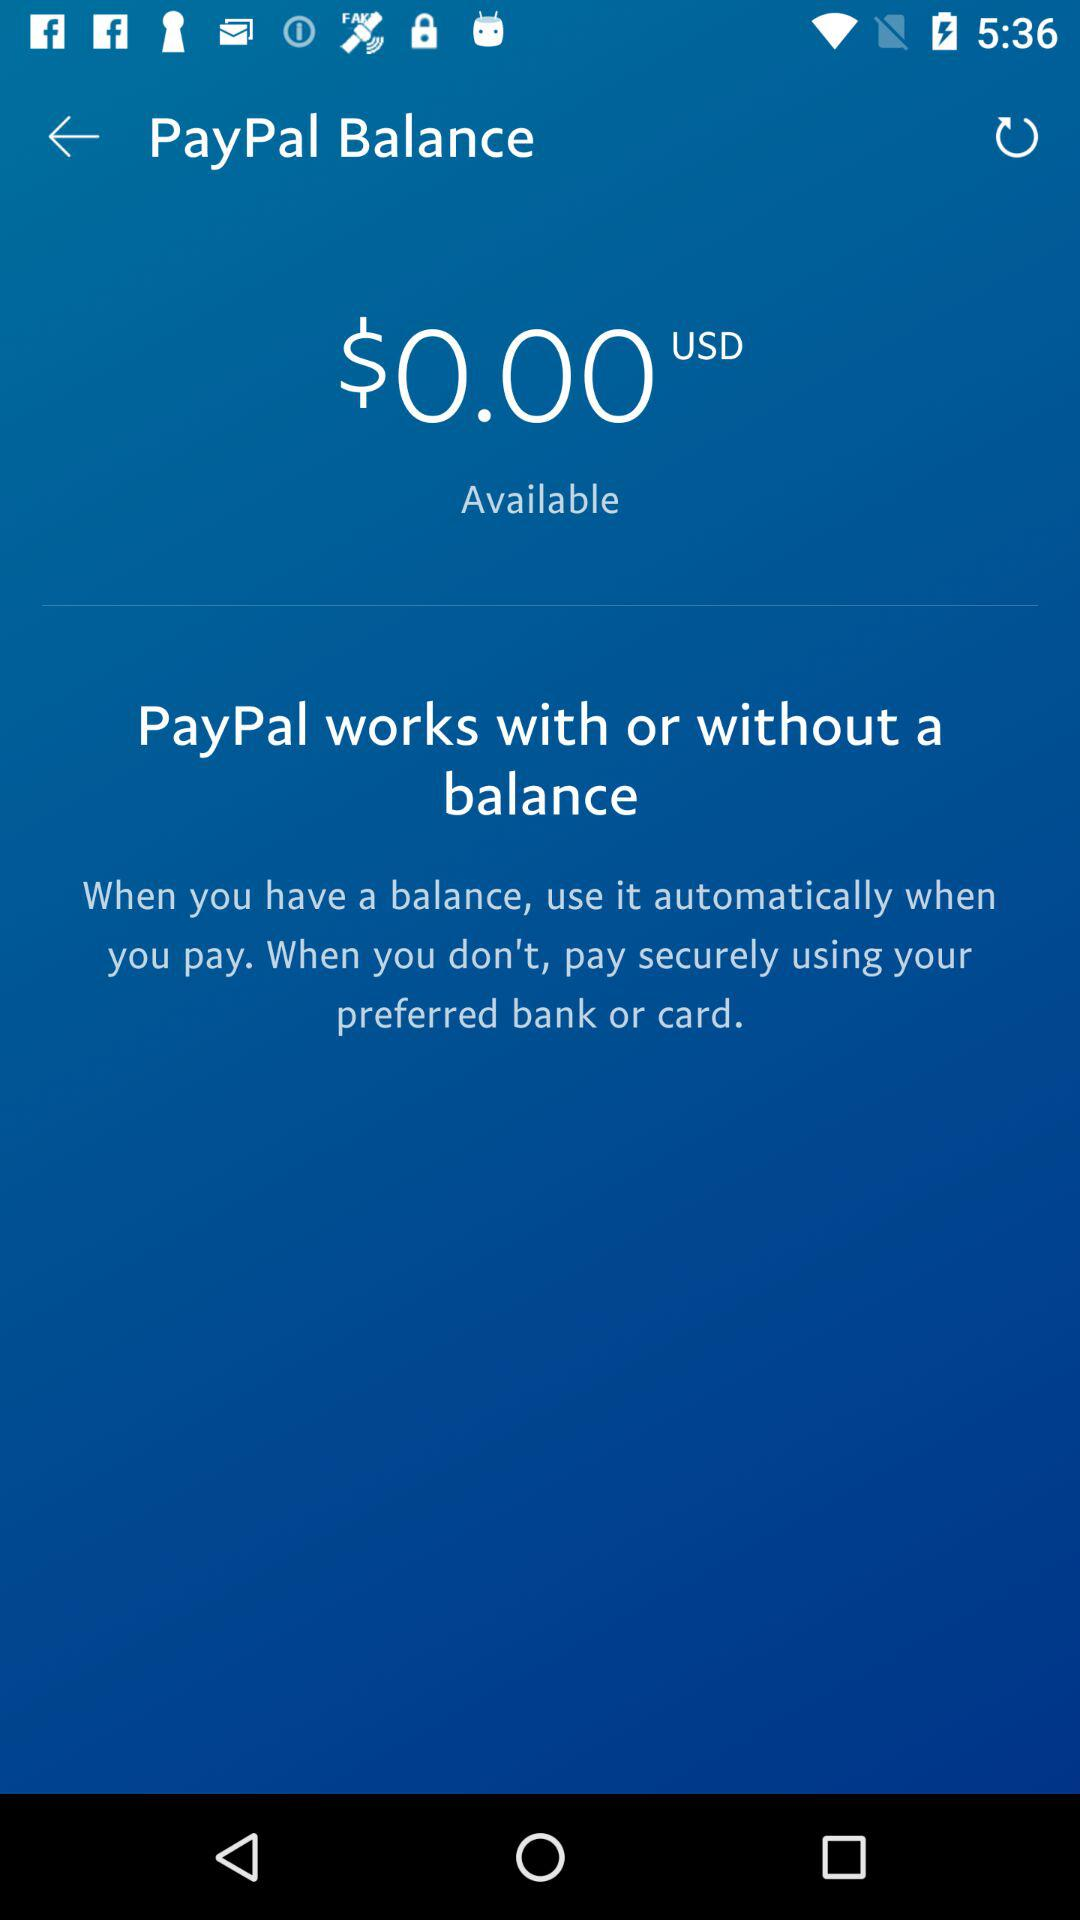What is the balance in USD?
Answer the question using a single word or phrase. $0.00 